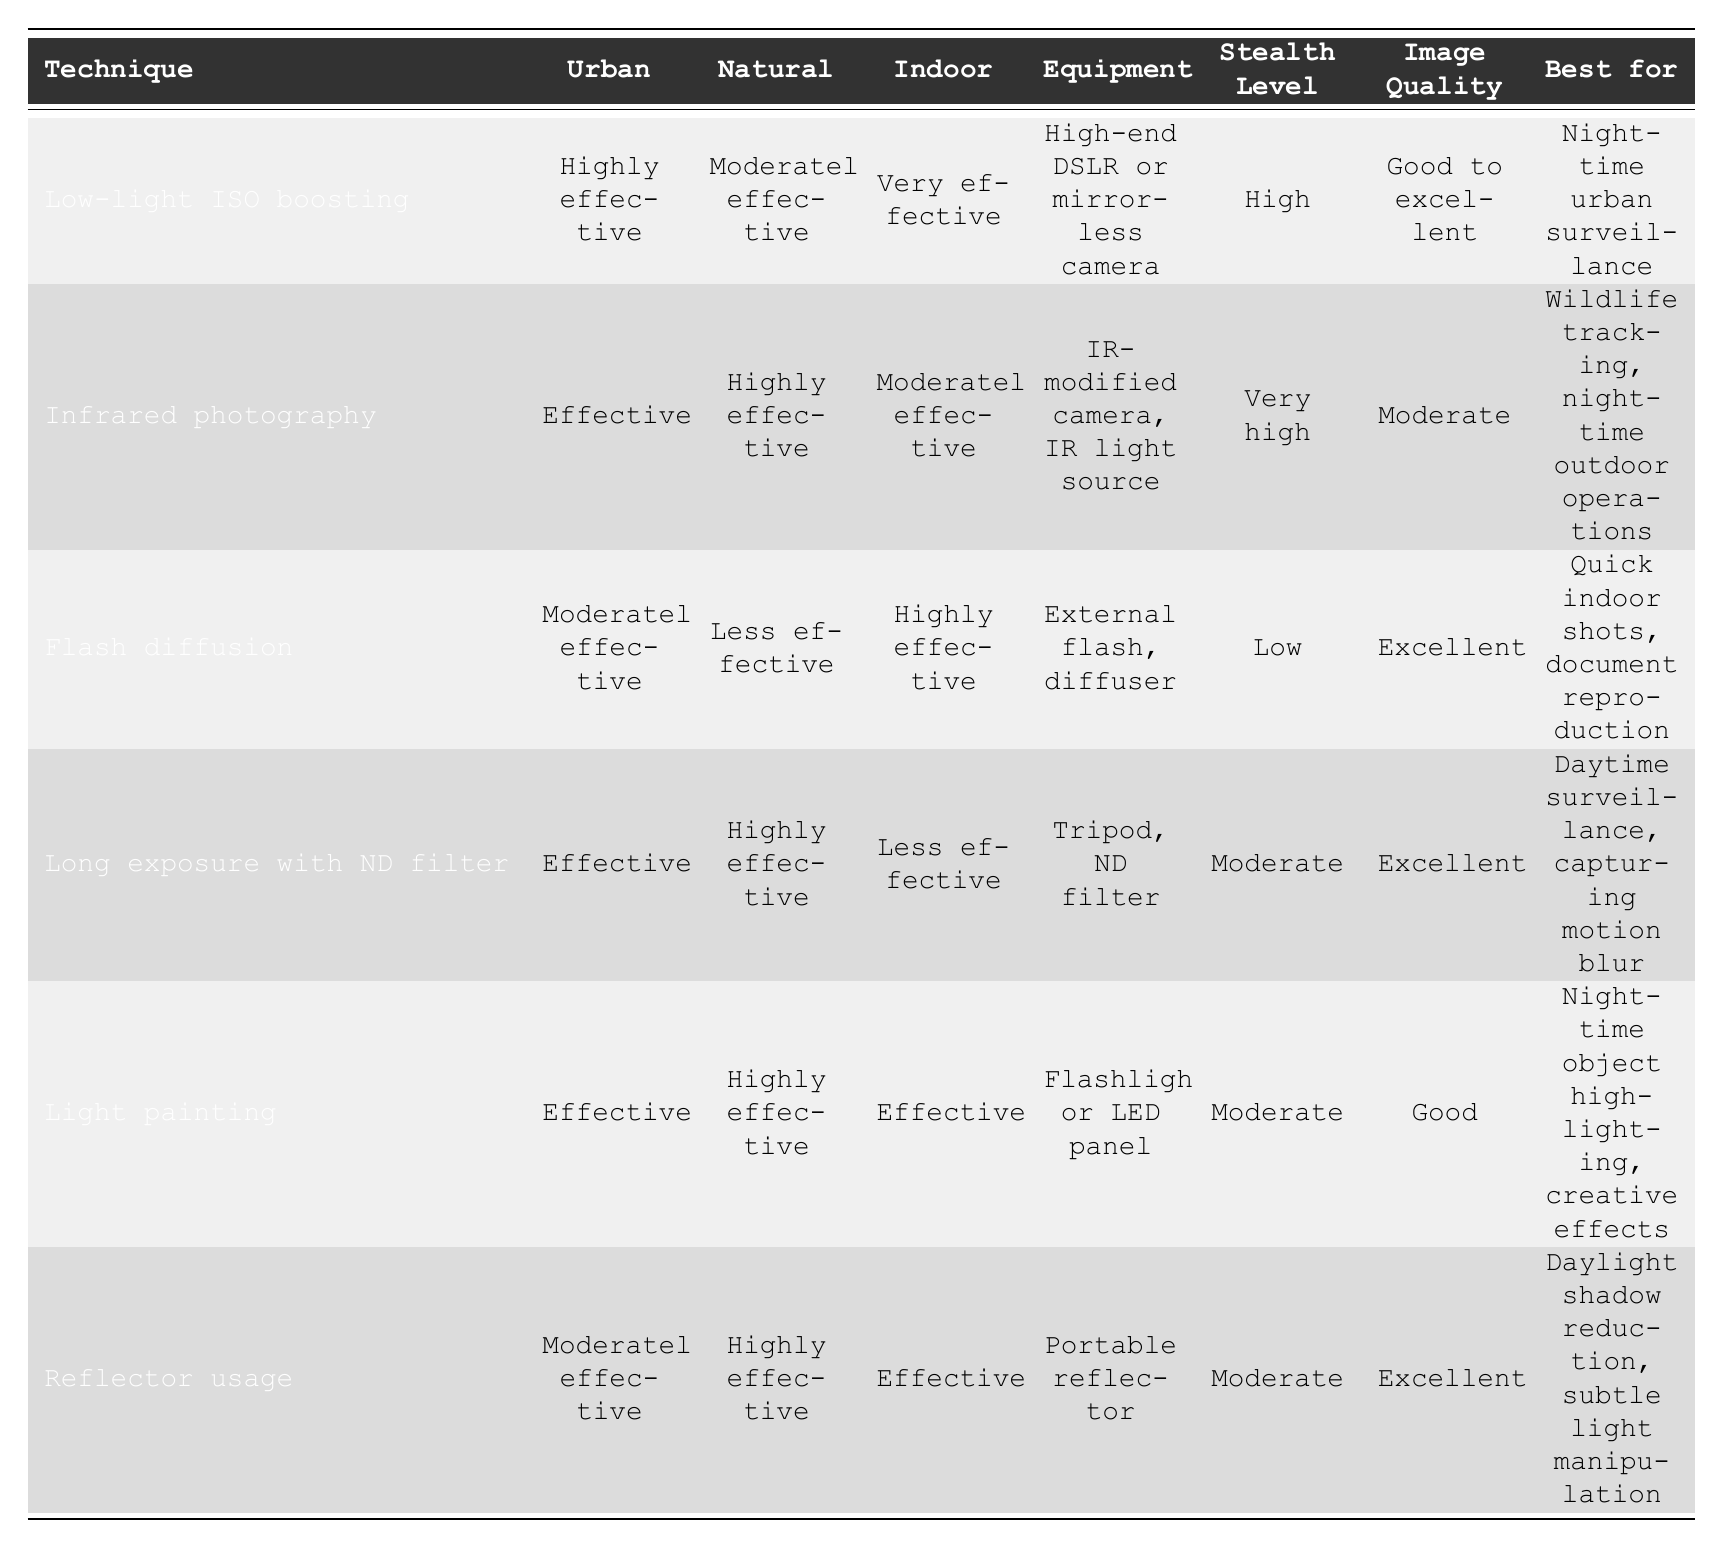What is the best lighting technique for night-time urban surveillance? Referring to the table, the "Low-light ISO boosting" is indicated as the best technique for night-time urban surveillance.
Answer: Low-light ISO boosting Which lighting technique has the highest stealth level, and what equipment is needed? The "Infrared photography" technique has a very high stealth level, and its required equipment is an IR-modified camera and an IR light source.
Answer: Infrared photography, IR-modified camera, IR light source Is "Flash diffusion" effective in a natural environment? The table shows that "Flash diffusion" is less effective in a natural environment.
Answer: No What is the average stealth level for the techniques listed in the table? The stealth levels are categorized as high, very high, low, moderate, and moderate. Assigning values: high (3), very high (4), low (1), moderate (2) gives values of (3 + 4 + 1 + 2 + 2) = 12. Dividing by the number of techniques (6), the average is 12/6 = 2.
Answer: 2 Which lighting techniques are effective in both urban and natural environments? The table shows that "Low-light ISO boosting," "Long exposure with ND filter," and "Light painting" are effective in both urban and natural environments.
Answer: Low-light ISO boosting, Long exposure with ND filter, Light painting 